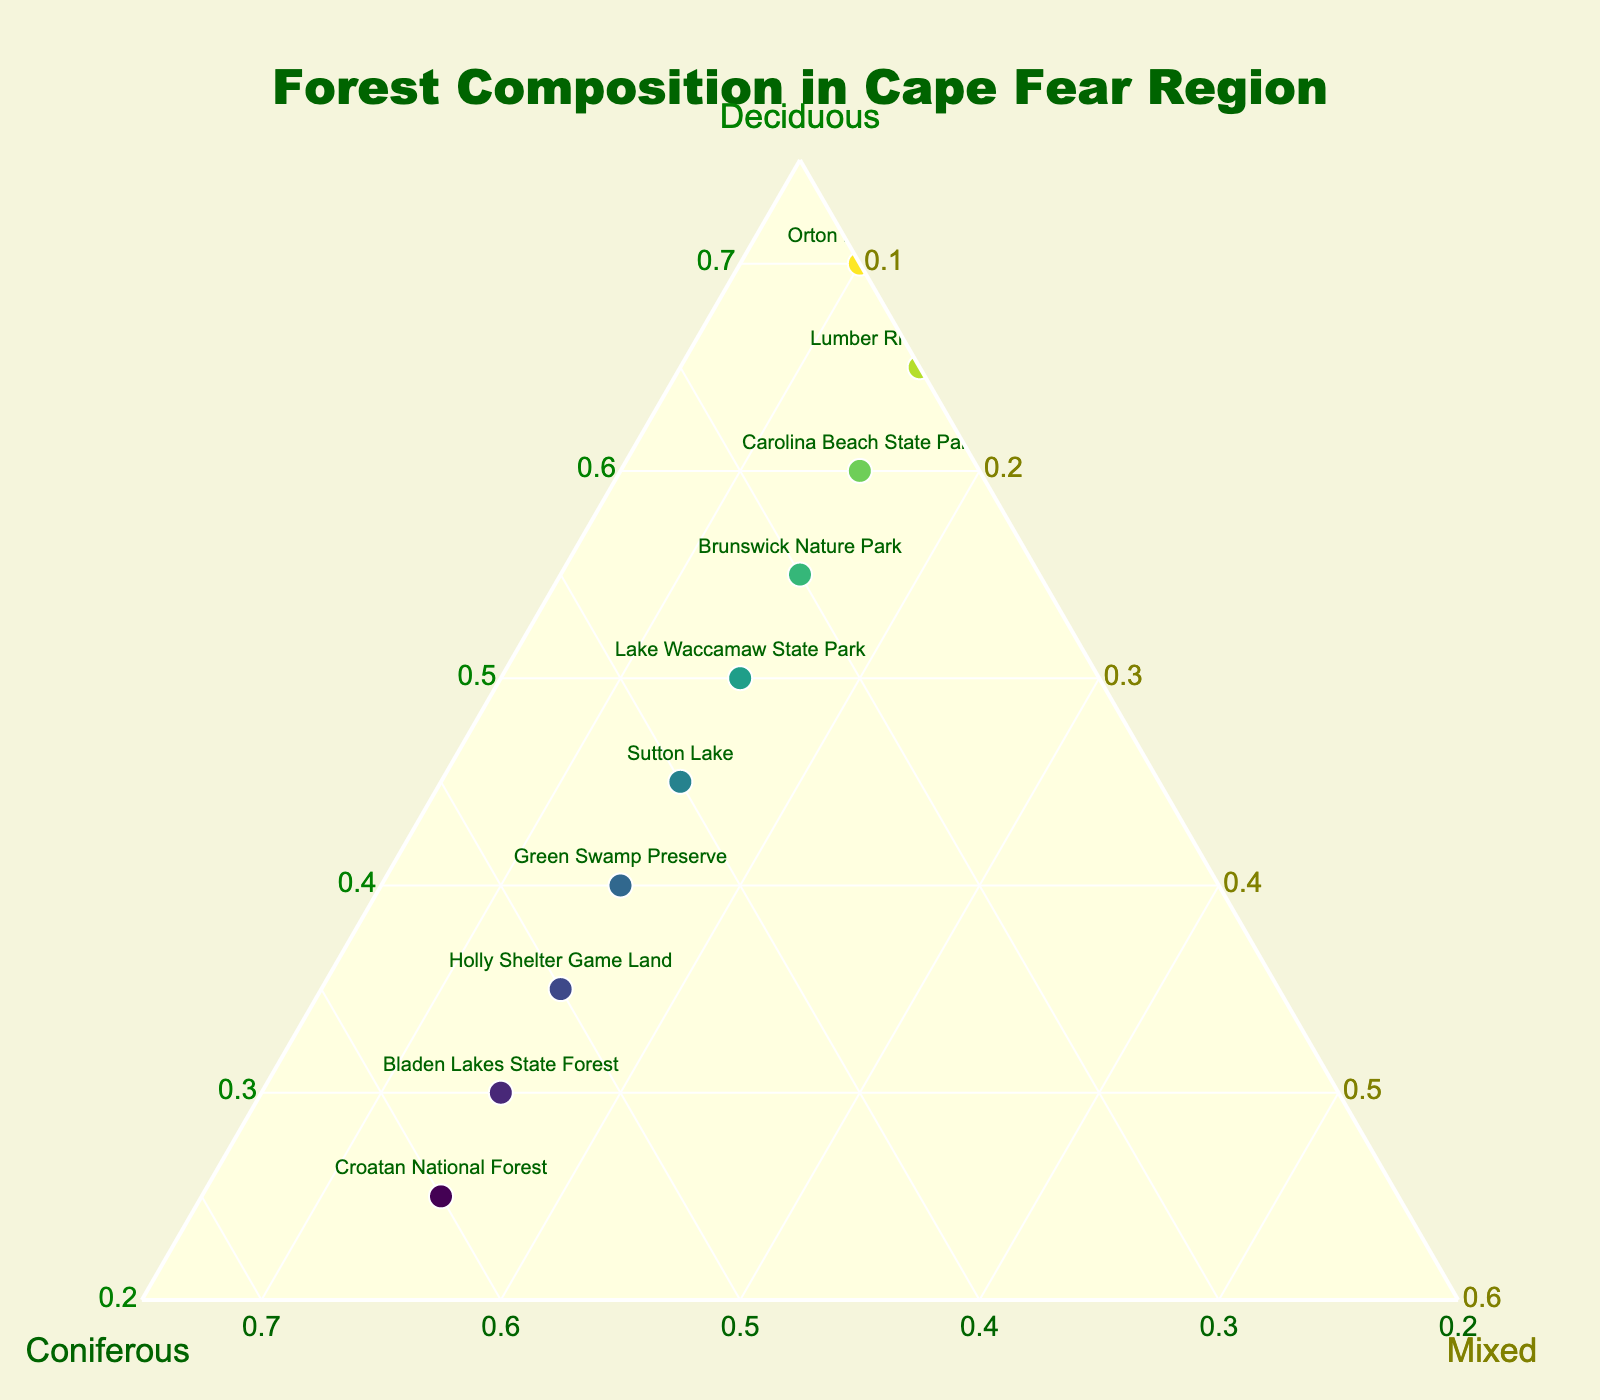What's the title of the figure? The title is usually text displayed prominently at the top of the figure. Look at the top-center of the plot to find it.
Answer: Forest Composition in Cape Fear Region How many locations are represented in the plot? Count the number of distinct markers in the ternary plot, each one represents a location.
Answer: 10 Which location has the highest percentage of coniferous forests? Identify the marker closest to the 'Coniferous' axis corner of the ternary plot. Check its label or hover text for confirmation.
Answer: Croatan National Forest What is the forest type composition of Orton Plantation? Find the marker labeled 'Orton Plantation' and refer to its hover text or position in the plot. It shows the percentages of the three forest types.
Answer: Deciduous: 70%, Coniferous: 20%, Mixed: 10% Which location has an equal percentage of mixed forests? Look for locations where the percentages of mixed forests are the same. This can be verified either by hover text or by looking at the 'Mixed' axis value.
Answer: Carolina Beach State Park, Green Swamp Preserve, Holly Shelter Game Land, Brunswick Nature Park, Sutton Lake, Lumber River State Park, Lake Waccamaw State Park, Bladen Lakes State Forest, Croatan National Forest (all have 15%) What's the average percentage of mixed forests across all locations? Sum all the mixed forest percentages and divide by the number of locations. The sum is (15+15+15+10+15+15+15+15+15+15) = 145. Divide by 10 for the average.
Answer: 14.5% Which location appears in the middle of the plot and what does that indicate? Identify the marker located near the central area of the ternary plot. This location typically has a balanced composition of all three forest types.
Answer: Lake Waccamaw State Park; indicates an almost equal mix of deciduous, coniferous, and mixed forests Which location has the least percentage of deciduous trees? Identify the marker closest to the 'Deciduous' axis corner, furthest away. Check its label or hover text for confirmation.
Answer: Croatan National Forest How do the forest compositions of Carolina Beach State Park and Orton Plantation compare? Locate both markers and compare their positions on the plot or check their hover texts. Carolina Beach State Park is 60% deciduous, 25% coniferous, and 15% mixed. Orton Plantation is 70% deciduous, 20% coniferous, and 10% mixed.
Answer: Orton Plantation has slightly more deciduous and fewer mixed and coniferous forests than Carolina Beach State Park 